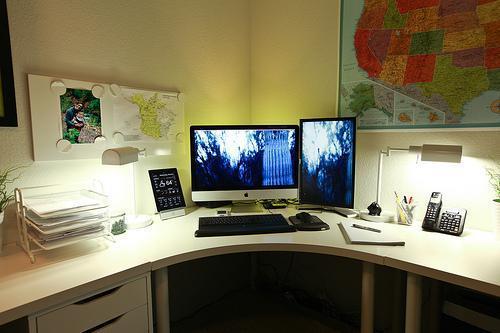How many monitors are there?
Give a very brief answer. 2. 